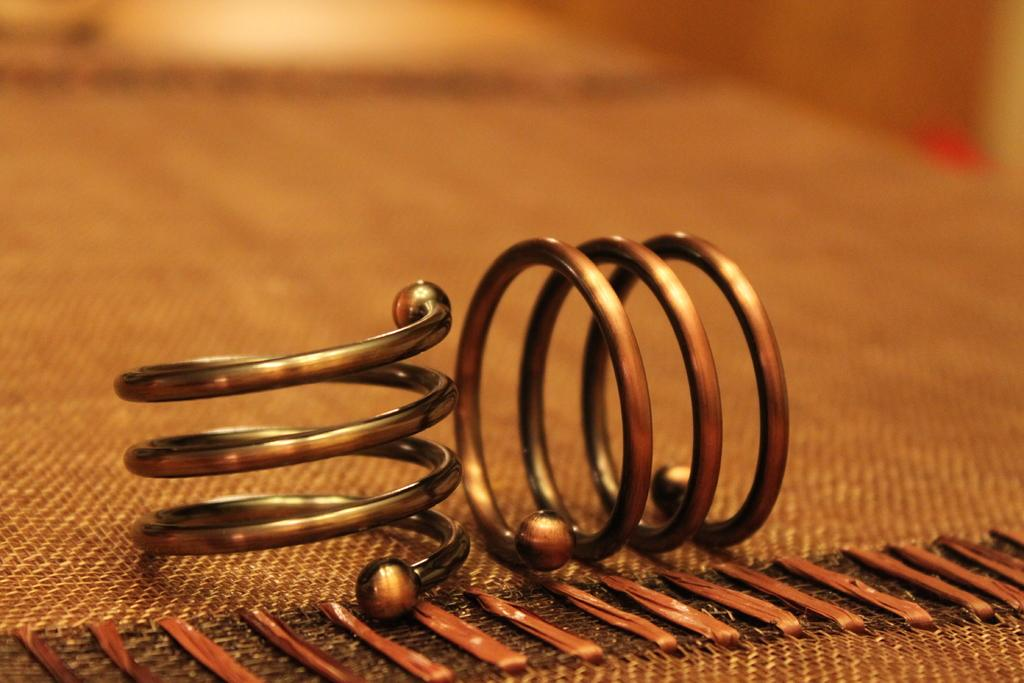What objects are present in the image? There are springs in the image. Where are the springs located? The springs are on a mat. What type of sleet can be seen falling on the springs in the image? There is no sleet present in the image; it only features springs on a mat. 